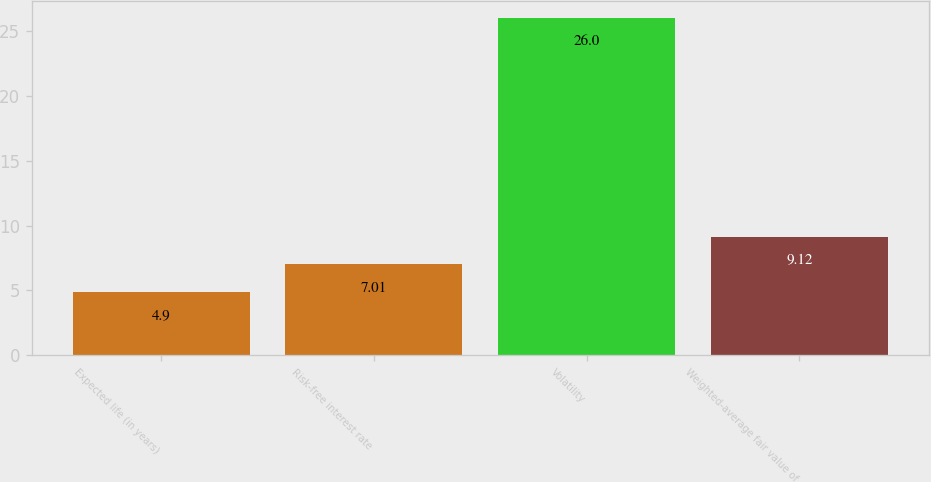<chart> <loc_0><loc_0><loc_500><loc_500><bar_chart><fcel>Expected life (in years)<fcel>Risk-free interest rate<fcel>Volatility<fcel>Weighted-average fair value of<nl><fcel>4.9<fcel>7.01<fcel>26<fcel>9.12<nl></chart> 